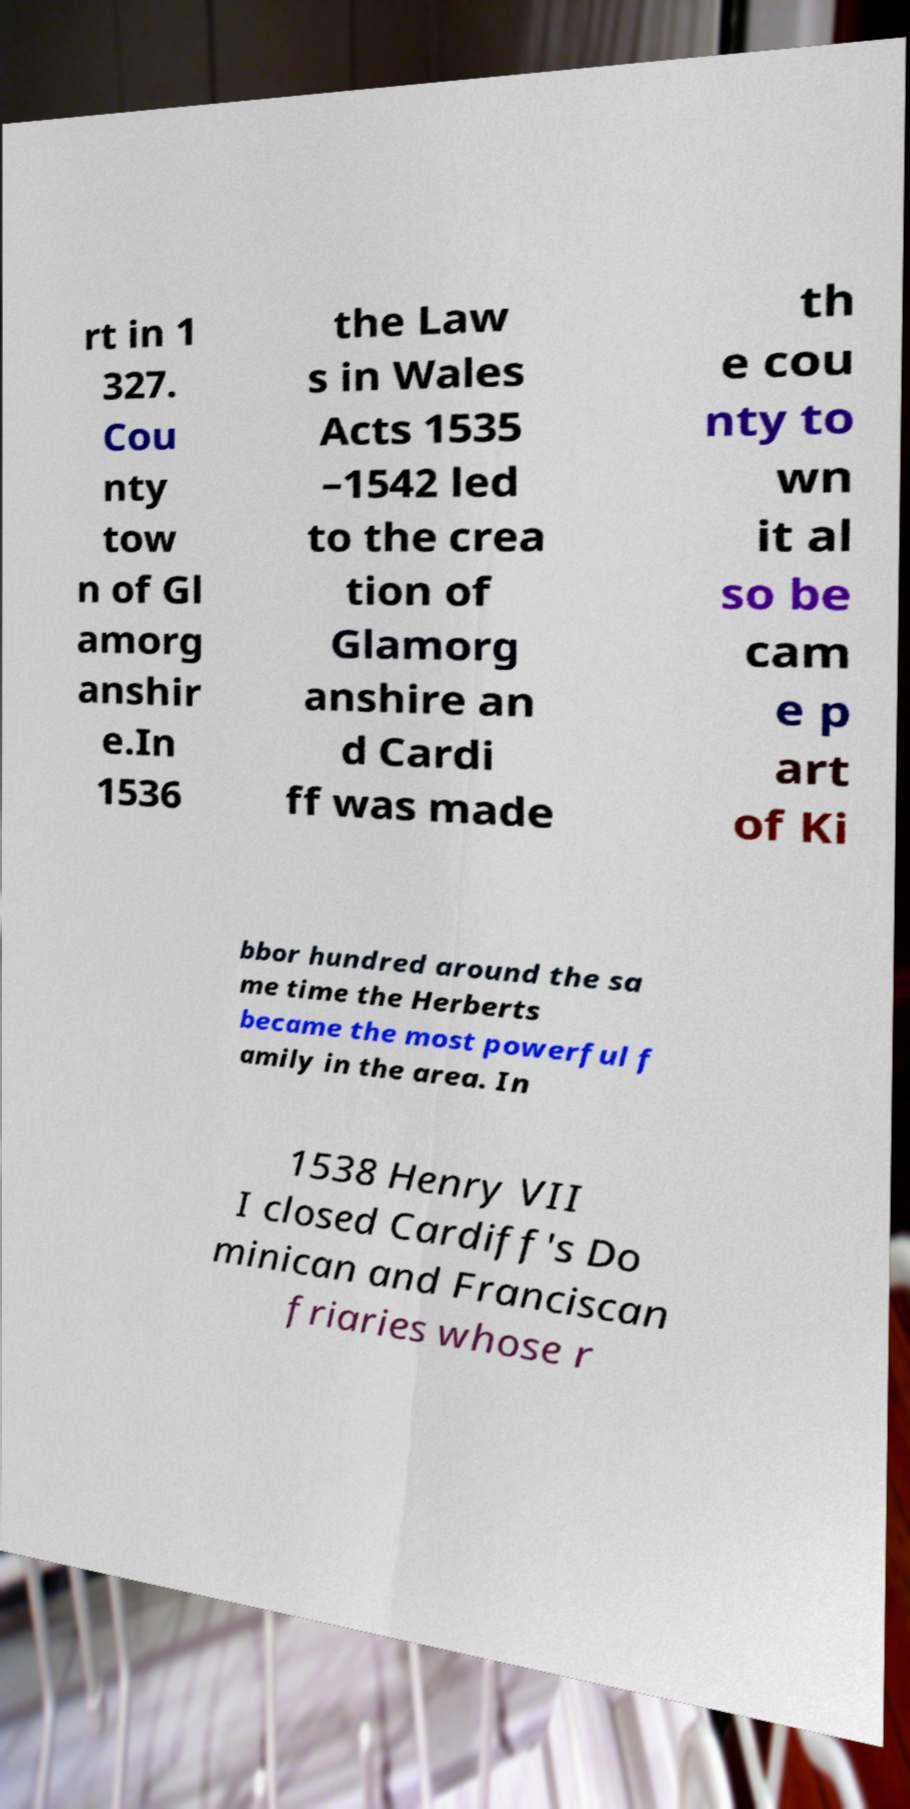What messages or text are displayed in this image? I need them in a readable, typed format. rt in 1 327. Cou nty tow n of Gl amorg anshir e.In 1536 the Law s in Wales Acts 1535 –1542 led to the crea tion of Glamorg anshire an d Cardi ff was made th e cou nty to wn it al so be cam e p art of Ki bbor hundred around the sa me time the Herberts became the most powerful f amily in the area. In 1538 Henry VII I closed Cardiff's Do minican and Franciscan friaries whose r 